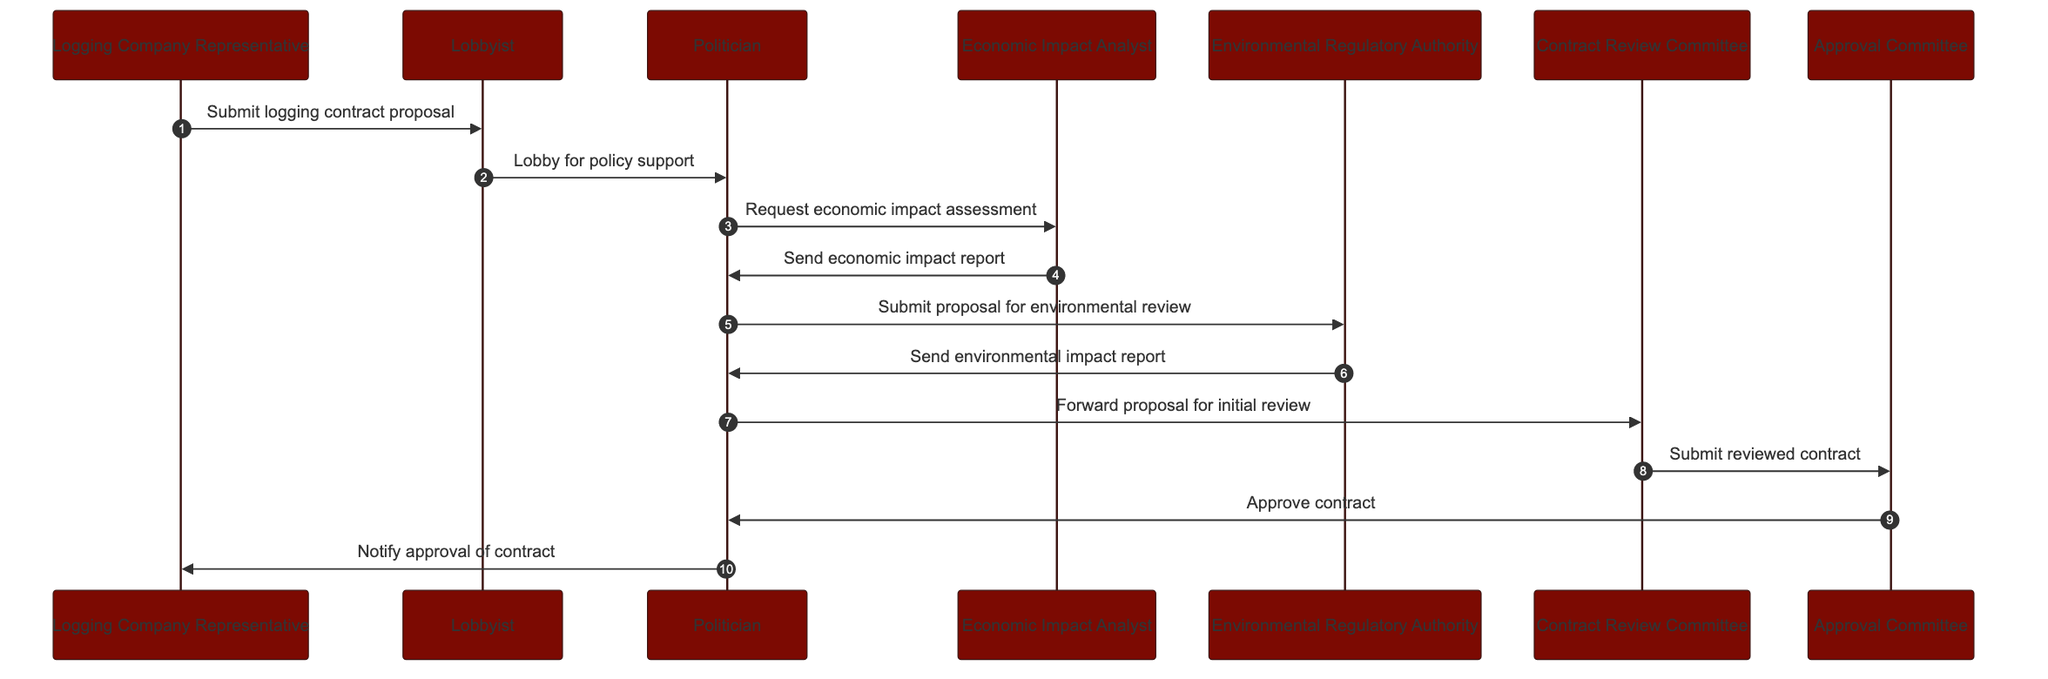What is the first message in the sequence? The first message is sent from the Logging Company Representative to the Lobbyist. This is identified as the first arrow pointing from the Logging Company Representative to the Lobbyist in the diagram.
Answer: Submit logging contract proposal How many actors are involved in this workflow? By counting the distinct participants listed in the diagram, there are a total of seven actors involved in the approval workflow for logging contracts.
Answer: Seven Who receives the economic impact report? The Economic Impact Analyst sends the economic impact report to the Politician, as indicated by the arrow from the Economic Impact Analyst to the Politician in the diagram.
Answer: Politician What is the last action taken before notifying the Logging Company Representative? The last action before notifying the Logging Company Representative is the Approval Committee approving the contract, indicated by the arrow connecting the Approval Committee to the Politician.
Answer: Approve contract Which actor submits the proposal for environmental review? The Politician is the actor that submits the proposal for environmental review, as shown by the message flowing from the Politician to the Environmental Regulatory Authority in the sequence.
Answer: Politician How many messages are exchanged between the Lobbyist and the Politician? There are two messages exchanged: the Lobbyist lobbies for policy support and the Politician requests economic impact assessment. Counting these sequentially shows this connection.
Answer: Two What type of report is sent by the Environmental Regulatory Authority? The Environmental Regulatory Authority sends an environmental impact report to the Politician, based on the connection between those two actors in the sequence.
Answer: Environmental impact report What action follows the contract review by the Committee? After the Contract Review Committee reviews the contract, they submit the reviewed contract to the Approval Committee, as indicated by the message flowing in that direction.
Answer: Submit reviewed contract What is the relationship between the Contract Review Committee and the Approval Committee? The Contract Review Committee submits the reviewed contract to the Approval Committee, establishing a direct flow of information from one committee to the other.
Answer: Submit reviewed contract 